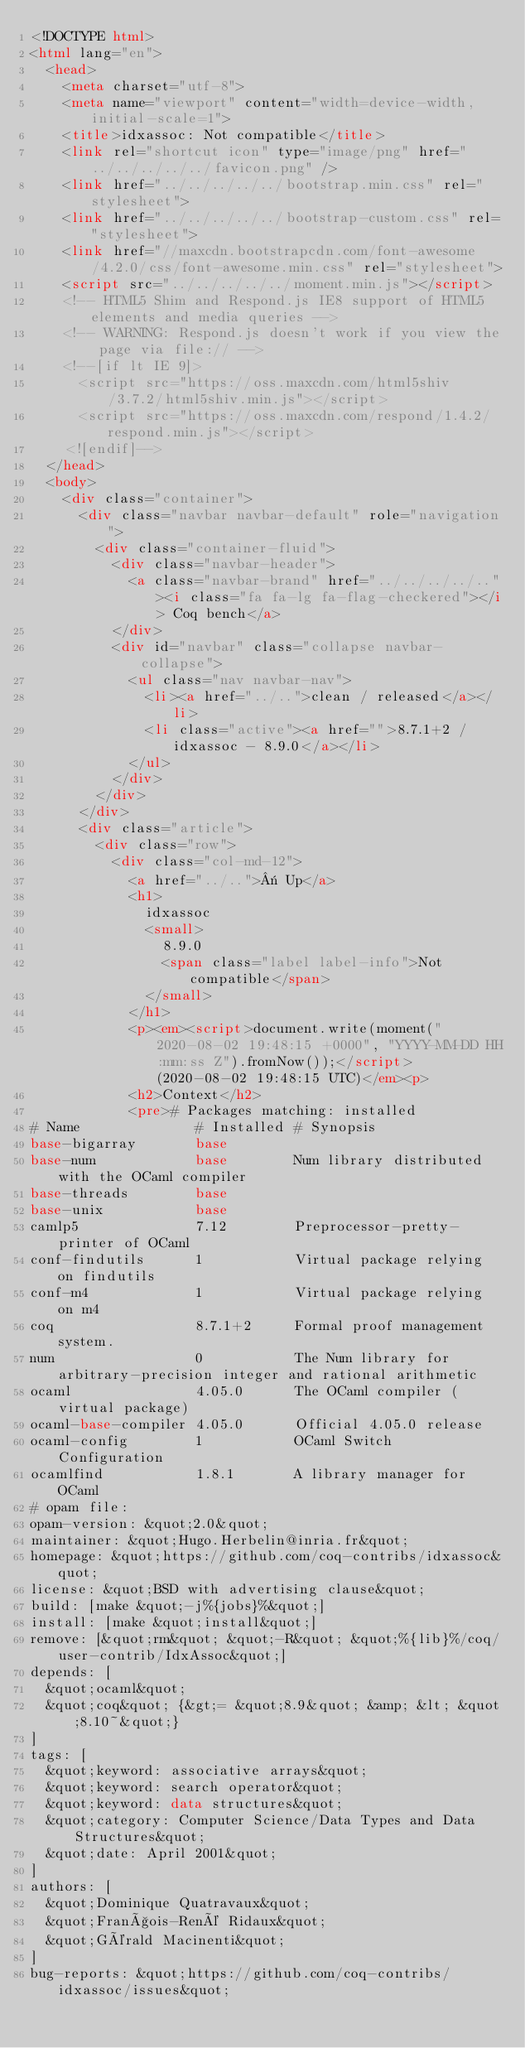Convert code to text. <code><loc_0><loc_0><loc_500><loc_500><_HTML_><!DOCTYPE html>
<html lang="en">
  <head>
    <meta charset="utf-8">
    <meta name="viewport" content="width=device-width, initial-scale=1">
    <title>idxassoc: Not compatible</title>
    <link rel="shortcut icon" type="image/png" href="../../../../../favicon.png" />
    <link href="../../../../../bootstrap.min.css" rel="stylesheet">
    <link href="../../../../../bootstrap-custom.css" rel="stylesheet">
    <link href="//maxcdn.bootstrapcdn.com/font-awesome/4.2.0/css/font-awesome.min.css" rel="stylesheet">
    <script src="../../../../../moment.min.js"></script>
    <!-- HTML5 Shim and Respond.js IE8 support of HTML5 elements and media queries -->
    <!-- WARNING: Respond.js doesn't work if you view the page via file:// -->
    <!--[if lt IE 9]>
      <script src="https://oss.maxcdn.com/html5shiv/3.7.2/html5shiv.min.js"></script>
      <script src="https://oss.maxcdn.com/respond/1.4.2/respond.min.js"></script>
    <![endif]-->
  </head>
  <body>
    <div class="container">
      <div class="navbar navbar-default" role="navigation">
        <div class="container-fluid">
          <div class="navbar-header">
            <a class="navbar-brand" href="../../../../.."><i class="fa fa-lg fa-flag-checkered"></i> Coq bench</a>
          </div>
          <div id="navbar" class="collapse navbar-collapse">
            <ul class="nav navbar-nav">
              <li><a href="../..">clean / released</a></li>
              <li class="active"><a href="">8.7.1+2 / idxassoc - 8.9.0</a></li>
            </ul>
          </div>
        </div>
      </div>
      <div class="article">
        <div class="row">
          <div class="col-md-12">
            <a href="../..">« Up</a>
            <h1>
              idxassoc
              <small>
                8.9.0
                <span class="label label-info">Not compatible</span>
              </small>
            </h1>
            <p><em><script>document.write(moment("2020-08-02 19:48:15 +0000", "YYYY-MM-DD HH:mm:ss Z").fromNow());</script> (2020-08-02 19:48:15 UTC)</em><p>
            <h2>Context</h2>
            <pre># Packages matching: installed
# Name              # Installed # Synopsis
base-bigarray       base
base-num            base        Num library distributed with the OCaml compiler
base-threads        base
base-unix           base
camlp5              7.12        Preprocessor-pretty-printer of OCaml
conf-findutils      1           Virtual package relying on findutils
conf-m4             1           Virtual package relying on m4
coq                 8.7.1+2     Formal proof management system.
num                 0           The Num library for arbitrary-precision integer and rational arithmetic
ocaml               4.05.0      The OCaml compiler (virtual package)
ocaml-base-compiler 4.05.0      Official 4.05.0 release
ocaml-config        1           OCaml Switch Configuration
ocamlfind           1.8.1       A library manager for OCaml
# opam file:
opam-version: &quot;2.0&quot;
maintainer: &quot;Hugo.Herbelin@inria.fr&quot;
homepage: &quot;https://github.com/coq-contribs/idxassoc&quot;
license: &quot;BSD with advertising clause&quot;
build: [make &quot;-j%{jobs}%&quot;]
install: [make &quot;install&quot;]
remove: [&quot;rm&quot; &quot;-R&quot; &quot;%{lib}%/coq/user-contrib/IdxAssoc&quot;]
depends: [
  &quot;ocaml&quot;
  &quot;coq&quot; {&gt;= &quot;8.9&quot; &amp; &lt; &quot;8.10~&quot;}
]
tags: [
  &quot;keyword: associative arrays&quot;
  &quot;keyword: search operator&quot;
  &quot;keyword: data structures&quot;
  &quot;category: Computer Science/Data Types and Data Structures&quot;
  &quot;date: April 2001&quot;
]
authors: [
  &quot;Dominique Quatravaux&quot;
  &quot;François-René Ridaux&quot;
  &quot;Gérald Macinenti&quot;
]
bug-reports: &quot;https://github.com/coq-contribs/idxassoc/issues&quot;</code> 